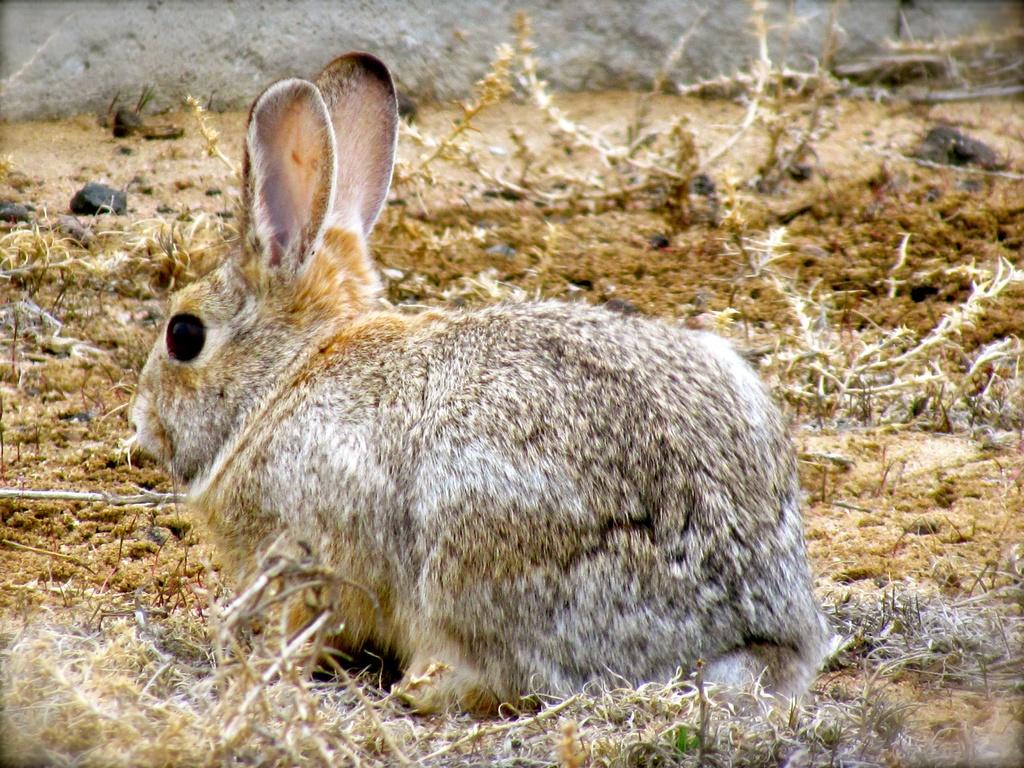What type of animal is in the image? There is a rabbit in the image. Where is the rabbit located? The rabbit is on the surface of the earth. What color is the rabbit's fifth tail in the image? Rabbits do not have multiple tails, and there is no mention of a fifth tail in the image. 